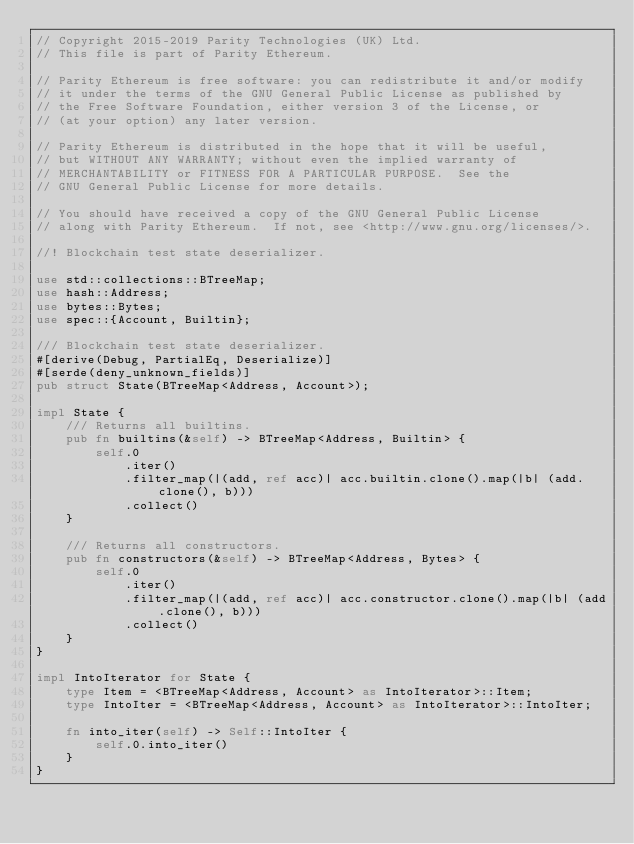Convert code to text. <code><loc_0><loc_0><loc_500><loc_500><_Rust_>// Copyright 2015-2019 Parity Technologies (UK) Ltd.
// This file is part of Parity Ethereum.

// Parity Ethereum is free software: you can redistribute it and/or modify
// it under the terms of the GNU General Public License as published by
// the Free Software Foundation, either version 3 of the License, or
// (at your option) any later version.

// Parity Ethereum is distributed in the hope that it will be useful,
// but WITHOUT ANY WARRANTY; without even the implied warranty of
// MERCHANTABILITY or FITNESS FOR A PARTICULAR PURPOSE.  See the
// GNU General Public License for more details.

// You should have received a copy of the GNU General Public License
// along with Parity Ethereum.  If not, see <http://www.gnu.org/licenses/>.

//! Blockchain test state deserializer.

use std::collections::BTreeMap;
use hash::Address;
use bytes::Bytes;
use spec::{Account, Builtin};

/// Blockchain test state deserializer.
#[derive(Debug, PartialEq, Deserialize)]
#[serde(deny_unknown_fields)]
pub struct State(BTreeMap<Address, Account>);

impl State {
	/// Returns all builtins.
	pub fn builtins(&self) -> BTreeMap<Address, Builtin> {
		self.0
			.iter()
			.filter_map(|(add, ref acc)| acc.builtin.clone().map(|b| (add.clone(), b)))
			.collect()
	}

	/// Returns all constructors.
	pub fn constructors(&self) -> BTreeMap<Address, Bytes> {
		self.0
			.iter()
			.filter_map(|(add, ref acc)| acc.constructor.clone().map(|b| (add.clone(), b)))
			.collect()
	}
}

impl IntoIterator for State {
	type Item = <BTreeMap<Address, Account> as IntoIterator>::Item;
	type IntoIter = <BTreeMap<Address, Account> as IntoIterator>::IntoIter;

	fn into_iter(self) -> Self::IntoIter {
		self.0.into_iter()
	}
}
</code> 